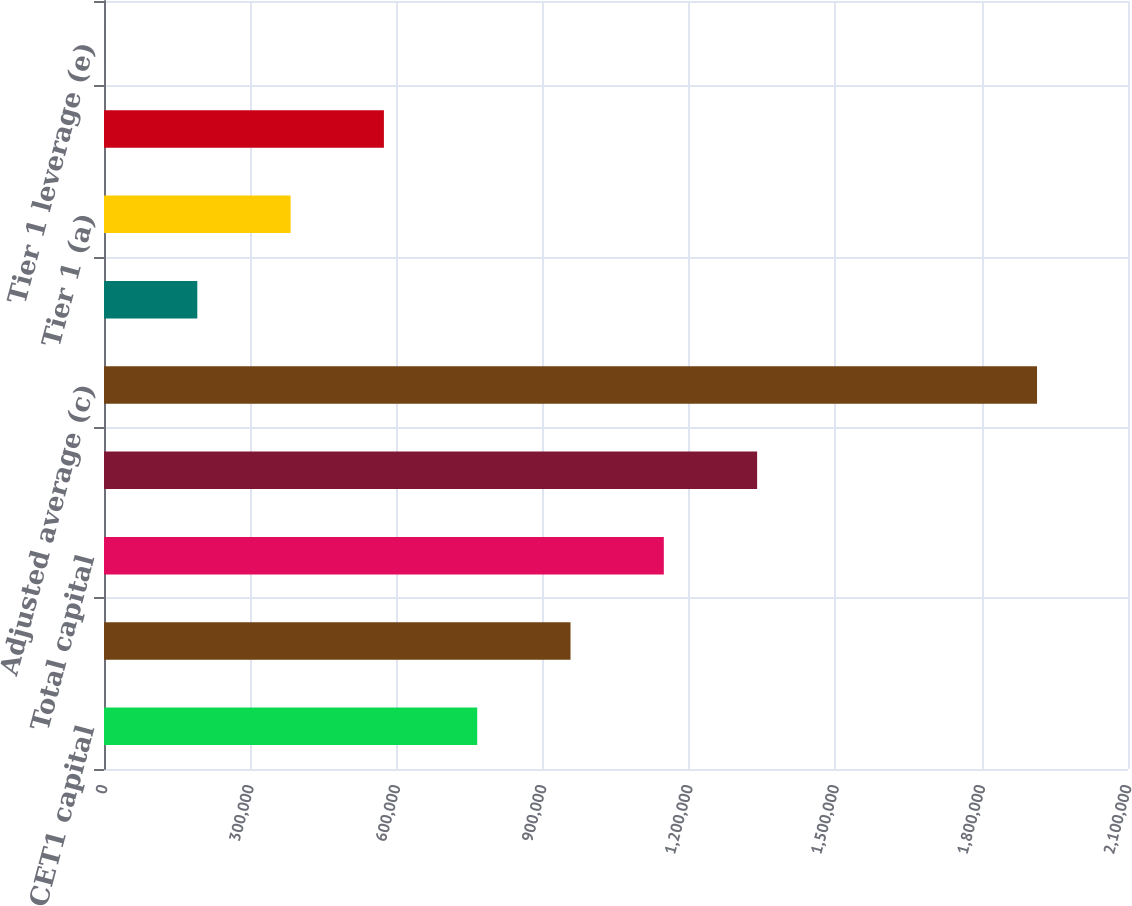Convert chart. <chart><loc_0><loc_0><loc_500><loc_500><bar_chart><fcel>CET1 capital<fcel>Tier 1 capital (a)<fcel>Total capital<fcel>Risk-weighted (b)<fcel>Adjusted average (c)<fcel>CET1<fcel>Tier 1 (a)<fcel>Total<fcel>Tier 1 leverage (e)<nl><fcel>765384<fcel>956728<fcel>1.14807e+06<fcel>1.33942e+06<fcel>1.91345e+06<fcel>191353<fcel>382697<fcel>574041<fcel>8.8<nl></chart> 